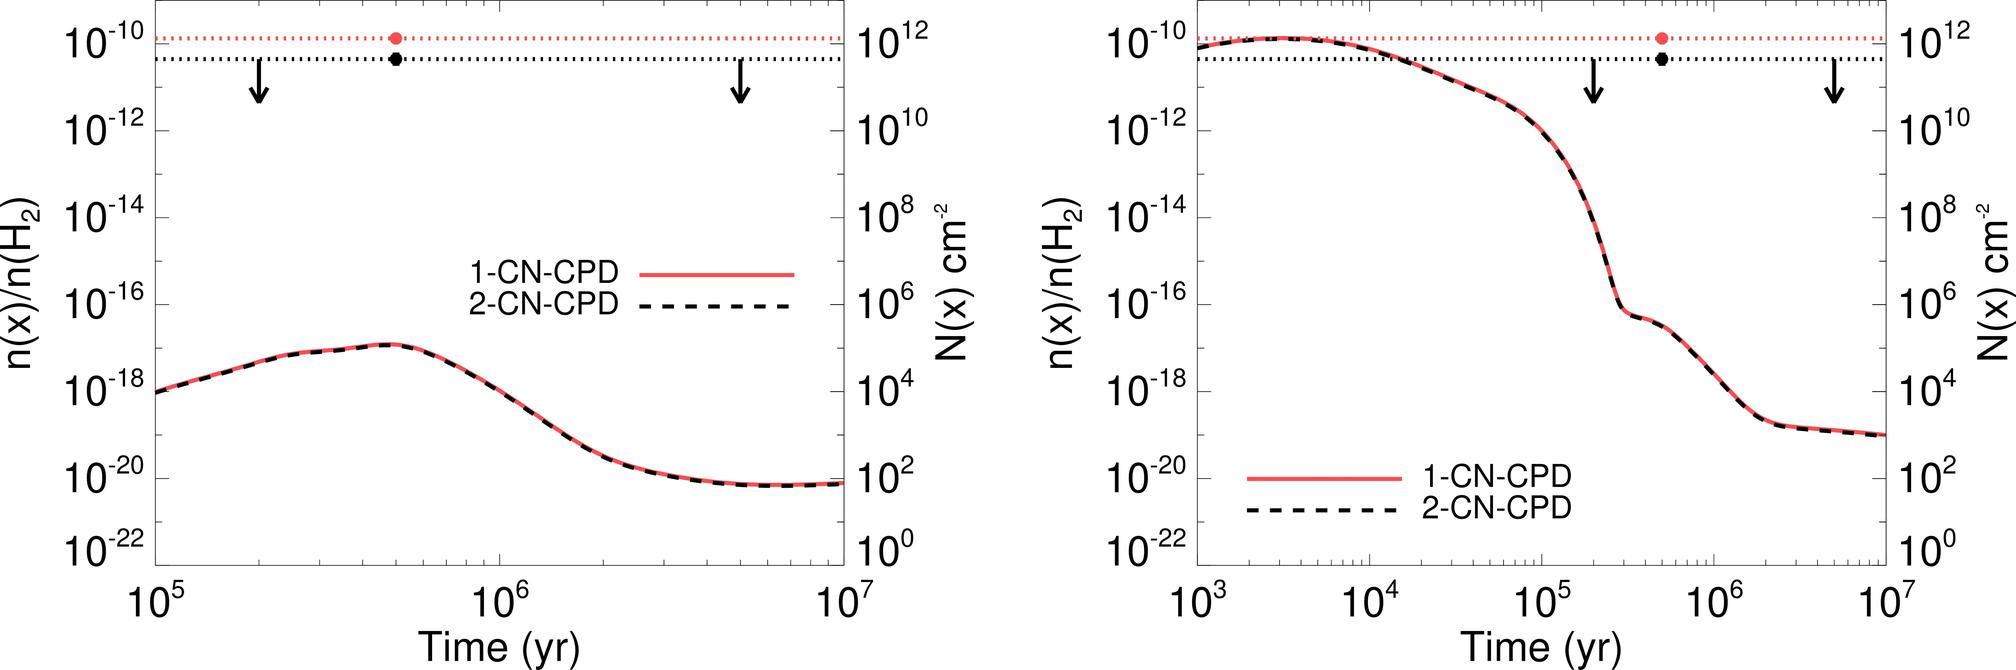Based on the trends shown in the graphs, what can be concluded about the time at which the concentration of both 1-CN-CPD and 2-CN-CPD begin to significantly decrease? A. At 10^5 years B. At 10^6 years C. After 10^7 years D. Between 10^5 and 10^6 years Upon reviewing the provided graphs, it is evident that the concentrations of both 1-CN-CPD and 2-CN-CPD start to exhibit a noteworthy decline within the time window between 10^5 and 10^6 years. This observation is deduced from the steep downwards slope on the graphs corresponding to each compound within that specific timespan, affirming option D as the correct answer. 